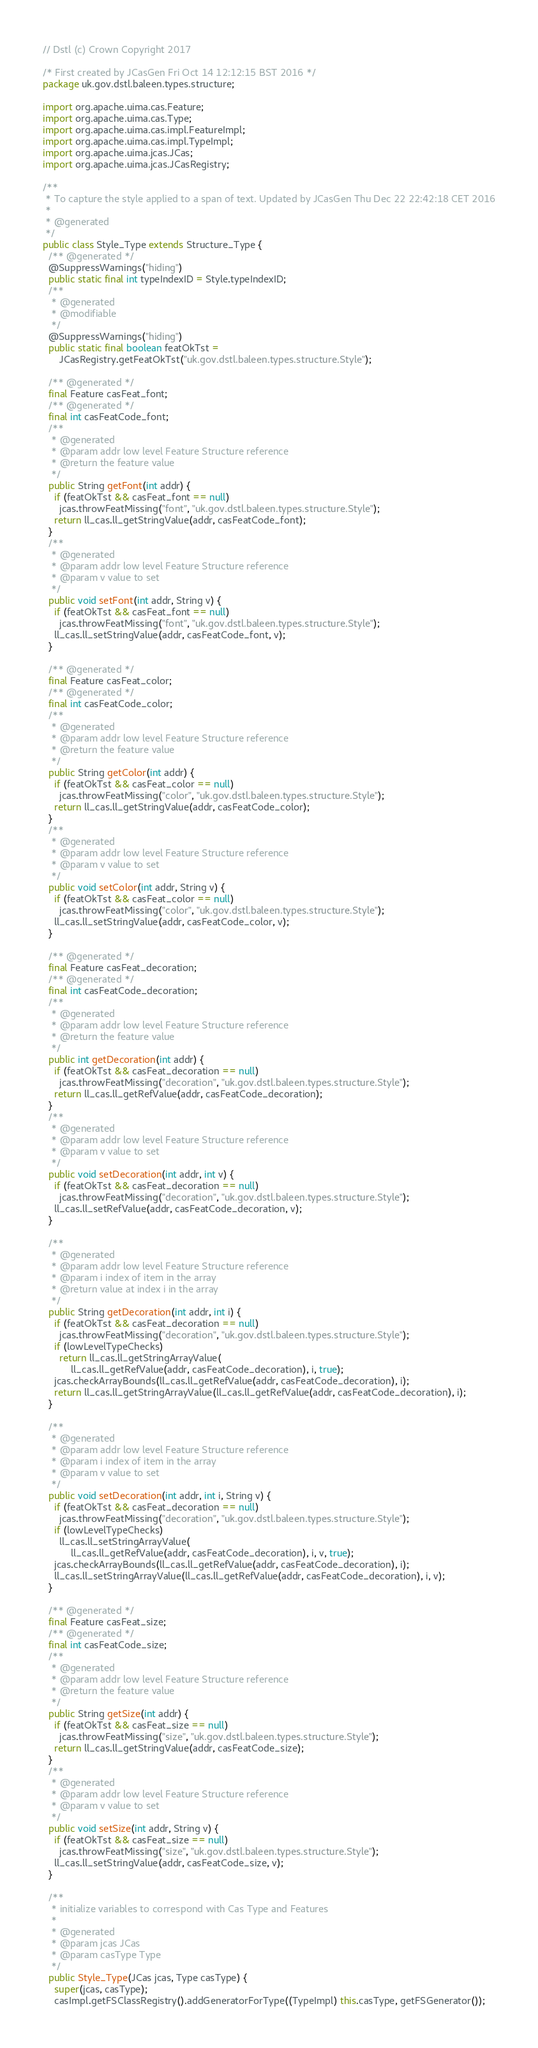Convert code to text. <code><loc_0><loc_0><loc_500><loc_500><_Java_>// Dstl (c) Crown Copyright 2017

/* First created by JCasGen Fri Oct 14 12:12:15 BST 2016 */
package uk.gov.dstl.baleen.types.structure;

import org.apache.uima.cas.Feature;
import org.apache.uima.cas.Type;
import org.apache.uima.cas.impl.FeatureImpl;
import org.apache.uima.cas.impl.TypeImpl;
import org.apache.uima.jcas.JCas;
import org.apache.uima.jcas.JCasRegistry;

/**
 * To capture the style applied to a span of text. Updated by JCasGen Thu Dec 22 22:42:18 CET 2016
 *
 * @generated
 */
public class Style_Type extends Structure_Type {
  /** @generated */
  @SuppressWarnings("hiding")
  public static final int typeIndexID = Style.typeIndexID;
  /**
   * @generated
   * @modifiable
   */
  @SuppressWarnings("hiding")
  public static final boolean featOkTst =
      JCasRegistry.getFeatOkTst("uk.gov.dstl.baleen.types.structure.Style");

  /** @generated */
  final Feature casFeat_font;
  /** @generated */
  final int casFeatCode_font;
  /**
   * @generated
   * @param addr low level Feature Structure reference
   * @return the feature value
   */
  public String getFont(int addr) {
    if (featOkTst && casFeat_font == null)
      jcas.throwFeatMissing("font", "uk.gov.dstl.baleen.types.structure.Style");
    return ll_cas.ll_getStringValue(addr, casFeatCode_font);
  }
  /**
   * @generated
   * @param addr low level Feature Structure reference
   * @param v value to set
   */
  public void setFont(int addr, String v) {
    if (featOkTst && casFeat_font == null)
      jcas.throwFeatMissing("font", "uk.gov.dstl.baleen.types.structure.Style");
    ll_cas.ll_setStringValue(addr, casFeatCode_font, v);
  }

  /** @generated */
  final Feature casFeat_color;
  /** @generated */
  final int casFeatCode_color;
  /**
   * @generated
   * @param addr low level Feature Structure reference
   * @return the feature value
   */
  public String getColor(int addr) {
    if (featOkTst && casFeat_color == null)
      jcas.throwFeatMissing("color", "uk.gov.dstl.baleen.types.structure.Style");
    return ll_cas.ll_getStringValue(addr, casFeatCode_color);
  }
  /**
   * @generated
   * @param addr low level Feature Structure reference
   * @param v value to set
   */
  public void setColor(int addr, String v) {
    if (featOkTst && casFeat_color == null)
      jcas.throwFeatMissing("color", "uk.gov.dstl.baleen.types.structure.Style");
    ll_cas.ll_setStringValue(addr, casFeatCode_color, v);
  }

  /** @generated */
  final Feature casFeat_decoration;
  /** @generated */
  final int casFeatCode_decoration;
  /**
   * @generated
   * @param addr low level Feature Structure reference
   * @return the feature value
   */
  public int getDecoration(int addr) {
    if (featOkTst && casFeat_decoration == null)
      jcas.throwFeatMissing("decoration", "uk.gov.dstl.baleen.types.structure.Style");
    return ll_cas.ll_getRefValue(addr, casFeatCode_decoration);
  }
  /**
   * @generated
   * @param addr low level Feature Structure reference
   * @param v value to set
   */
  public void setDecoration(int addr, int v) {
    if (featOkTst && casFeat_decoration == null)
      jcas.throwFeatMissing("decoration", "uk.gov.dstl.baleen.types.structure.Style");
    ll_cas.ll_setRefValue(addr, casFeatCode_decoration, v);
  }

  /**
   * @generated
   * @param addr low level Feature Structure reference
   * @param i index of item in the array
   * @return value at index i in the array
   */
  public String getDecoration(int addr, int i) {
    if (featOkTst && casFeat_decoration == null)
      jcas.throwFeatMissing("decoration", "uk.gov.dstl.baleen.types.structure.Style");
    if (lowLevelTypeChecks)
      return ll_cas.ll_getStringArrayValue(
          ll_cas.ll_getRefValue(addr, casFeatCode_decoration), i, true);
    jcas.checkArrayBounds(ll_cas.ll_getRefValue(addr, casFeatCode_decoration), i);
    return ll_cas.ll_getStringArrayValue(ll_cas.ll_getRefValue(addr, casFeatCode_decoration), i);
  }

  /**
   * @generated
   * @param addr low level Feature Structure reference
   * @param i index of item in the array
   * @param v value to set
   */
  public void setDecoration(int addr, int i, String v) {
    if (featOkTst && casFeat_decoration == null)
      jcas.throwFeatMissing("decoration", "uk.gov.dstl.baleen.types.structure.Style");
    if (lowLevelTypeChecks)
      ll_cas.ll_setStringArrayValue(
          ll_cas.ll_getRefValue(addr, casFeatCode_decoration), i, v, true);
    jcas.checkArrayBounds(ll_cas.ll_getRefValue(addr, casFeatCode_decoration), i);
    ll_cas.ll_setStringArrayValue(ll_cas.ll_getRefValue(addr, casFeatCode_decoration), i, v);
  }

  /** @generated */
  final Feature casFeat_size;
  /** @generated */
  final int casFeatCode_size;
  /**
   * @generated
   * @param addr low level Feature Structure reference
   * @return the feature value
   */
  public String getSize(int addr) {
    if (featOkTst && casFeat_size == null)
      jcas.throwFeatMissing("size", "uk.gov.dstl.baleen.types.structure.Style");
    return ll_cas.ll_getStringValue(addr, casFeatCode_size);
  }
  /**
   * @generated
   * @param addr low level Feature Structure reference
   * @param v value to set
   */
  public void setSize(int addr, String v) {
    if (featOkTst && casFeat_size == null)
      jcas.throwFeatMissing("size", "uk.gov.dstl.baleen.types.structure.Style");
    ll_cas.ll_setStringValue(addr, casFeatCode_size, v);
  }

  /**
   * initialize variables to correspond with Cas Type and Features
   *
   * @generated
   * @param jcas JCas
   * @param casType Type
   */
  public Style_Type(JCas jcas, Type casType) {
    super(jcas, casType);
    casImpl.getFSClassRegistry().addGeneratorForType((TypeImpl) this.casType, getFSGenerator());
</code> 